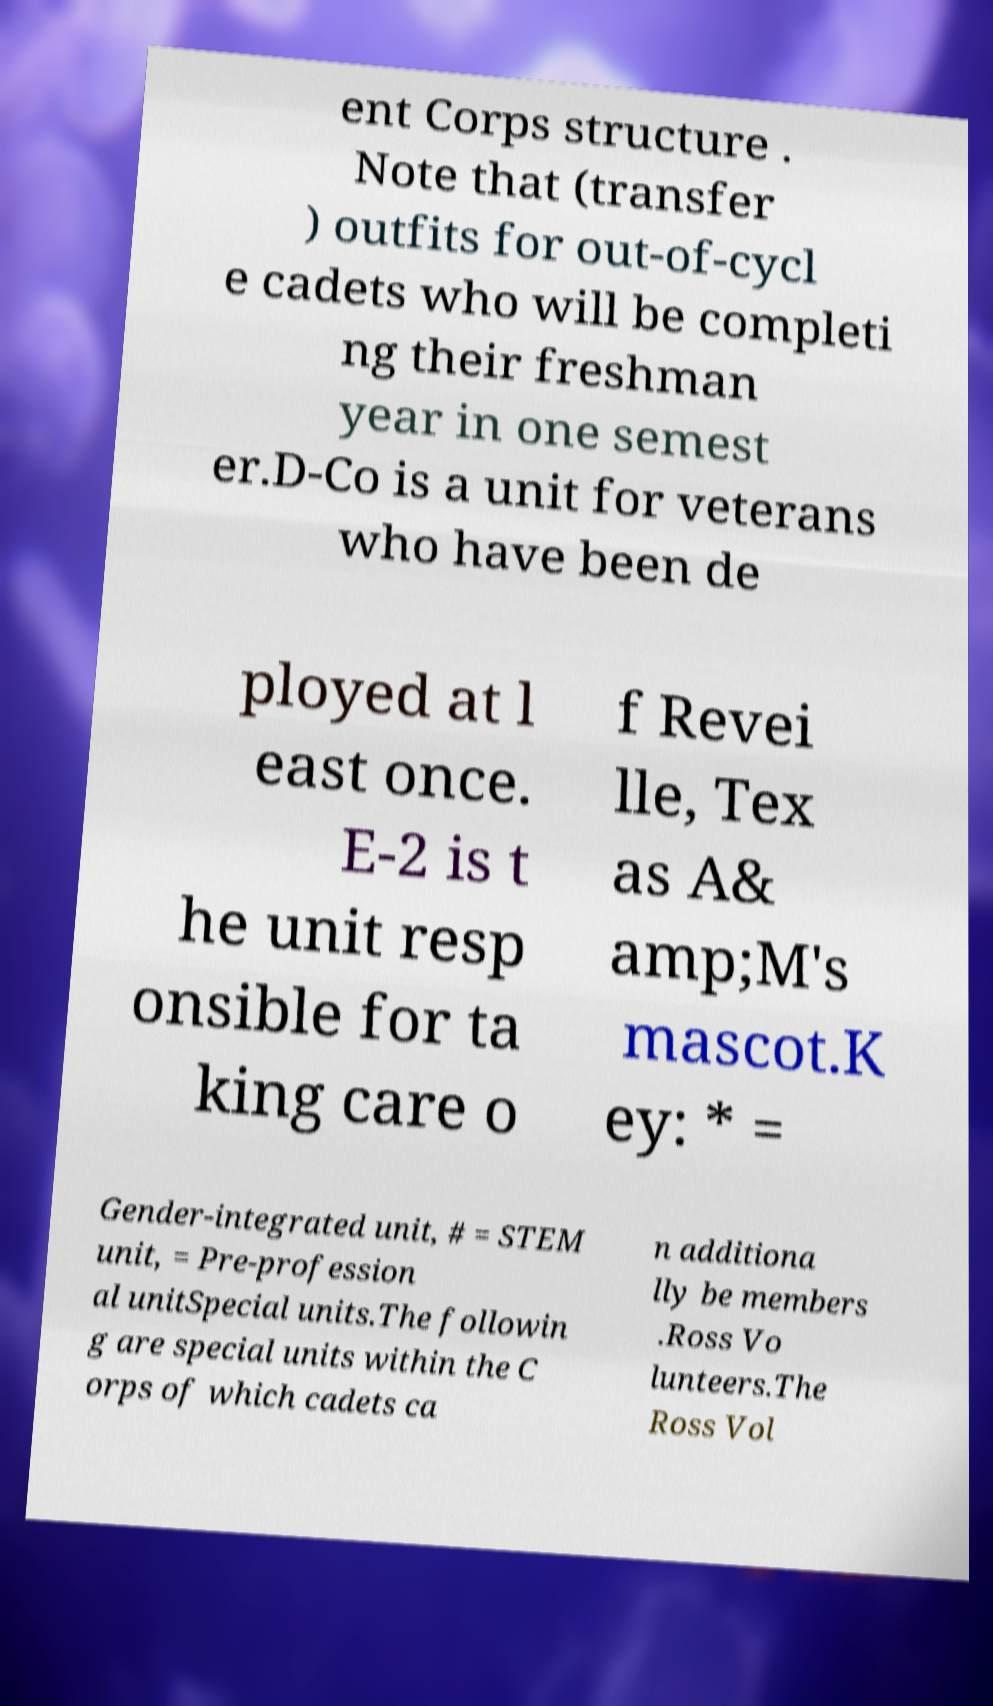There's text embedded in this image that I need extracted. Can you transcribe it verbatim? ent Corps structure . Note that (transfer ) outfits for out-of-cycl e cadets who will be completi ng their freshman year in one semest er.D-Co is a unit for veterans who have been de ployed at l east once. E-2 is t he unit resp onsible for ta king care o f Revei lle, Tex as A& amp;M's mascot.K ey: * = Gender-integrated unit, # = STEM unit, = Pre-profession al unitSpecial units.The followin g are special units within the C orps of which cadets ca n additiona lly be members .Ross Vo lunteers.The Ross Vol 